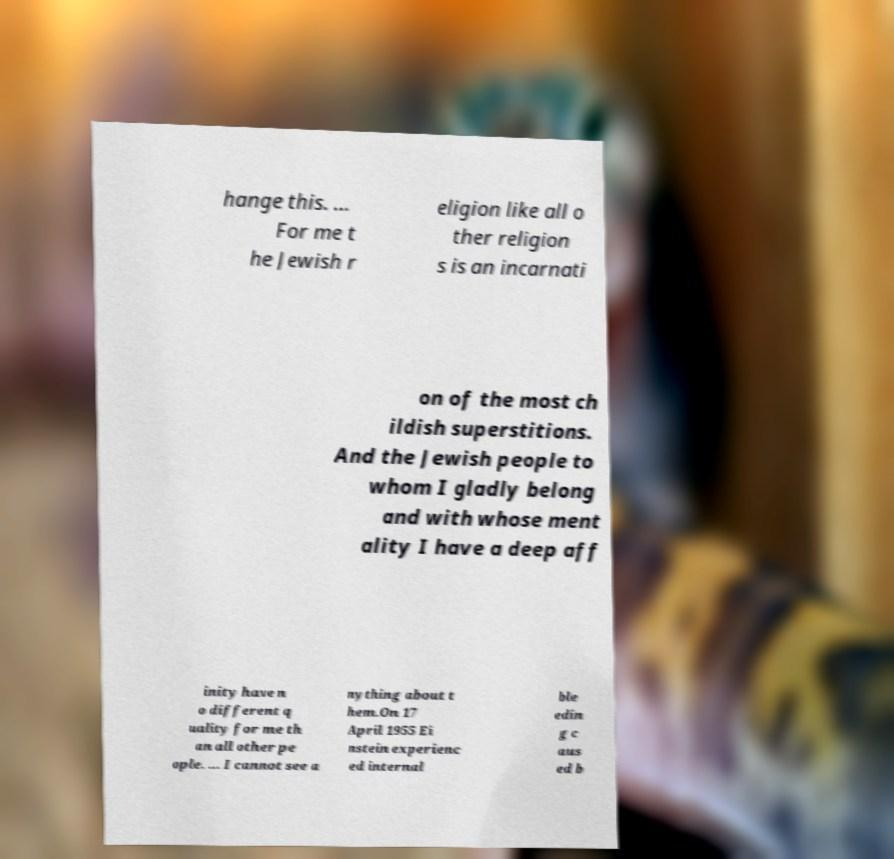Can you accurately transcribe the text from the provided image for me? hange this. ... For me t he Jewish r eligion like all o ther religion s is an incarnati on of the most ch ildish superstitions. And the Jewish people to whom I gladly belong and with whose ment ality I have a deep aff inity have n o different q uality for me th an all other pe ople. ... I cannot see a nything about t hem.On 17 April 1955 Ei nstein experienc ed internal ble edin g c aus ed b 